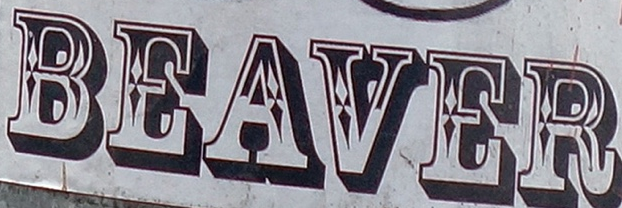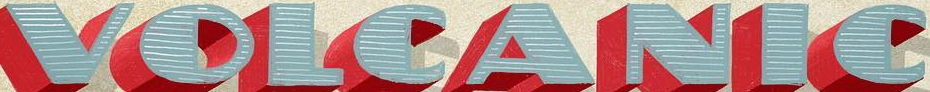Read the text from these images in sequence, separated by a semicolon. BEAVER; VOLCANIC 